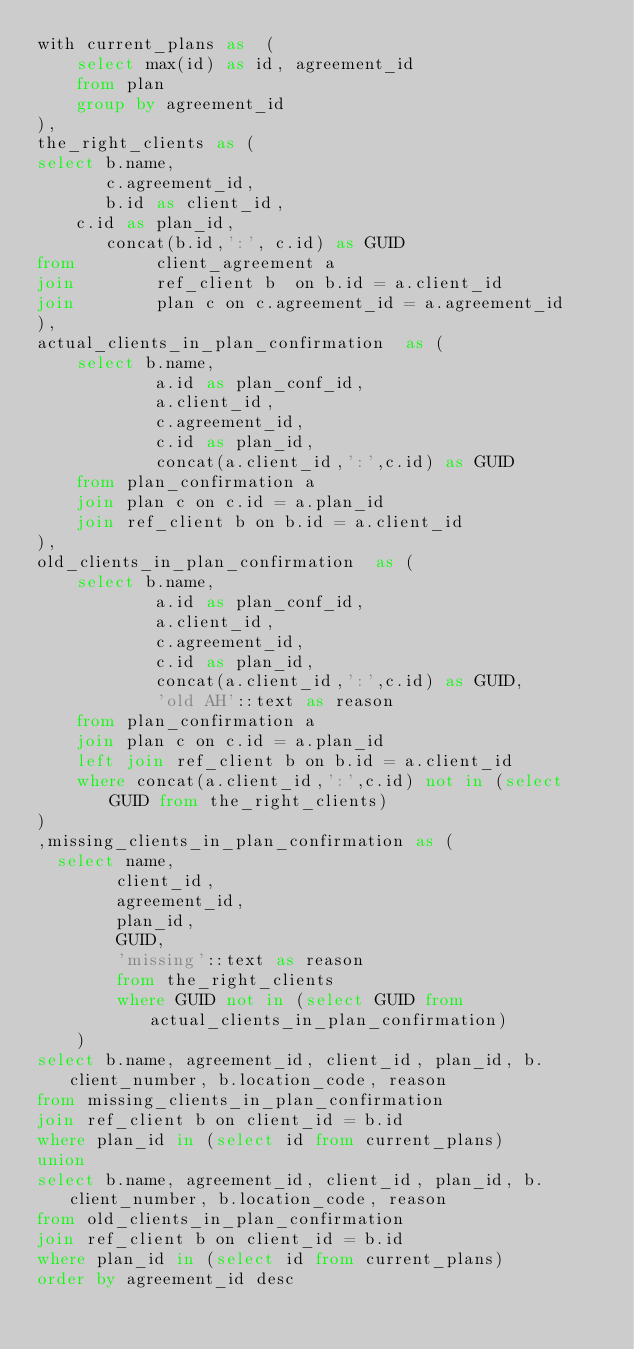<code> <loc_0><loc_0><loc_500><loc_500><_SQL_>with current_plans as  (
    select max(id) as id, agreement_id 
    from plan
    group by agreement_id
),
the_right_clients as ( 
select b.name, 
       c.agreement_id,
       b.id as client_id,
    c.id as plan_id,
       concat(b.id,':', c.id) as GUID
from        client_agreement a 
join        ref_client b  on b.id = a.client_id
join        plan c on c.agreement_id = a.agreement_id
),
actual_clients_in_plan_confirmation  as (
    select b.name,
            a.id as plan_conf_id,
            a.client_id,
            c.agreement_id,
            c.id as plan_id,
            concat(a.client_id,':',c.id) as GUID
    from plan_confirmation a
    join plan c on c.id = a.plan_id
    join ref_client b on b.id = a.client_id
),
old_clients_in_plan_confirmation  as (
    select b.name,
            a.id as plan_conf_id,
            a.client_id,
            c.agreement_id,
            c.id as plan_id,
            concat(a.client_id,':',c.id) as GUID,
            'old AH'::text as reason
    from plan_confirmation a
    join plan c on c.id = a.plan_id
    left join ref_client b on b.id = a.client_id
    where concat(a.client_id,':',c.id) not in (select GUID from the_right_clients)
)
,missing_clients_in_plan_confirmation as (
  select name,
        client_id,
        agreement_id,
        plan_id,
        GUID,
        'missing'::text as reason
        from the_right_clients
        where GUID not in (select GUID from actual_clients_in_plan_confirmation)
    )
select b.name, agreement_id, client_id, plan_id, b.client_number, b.location_code, reason
from missing_clients_in_plan_confirmation
join ref_client b on client_id = b.id
where plan_id in (select id from current_plans)
union
select b.name, agreement_id, client_id, plan_id, b.client_number, b.location_code, reason
from old_clients_in_plan_confirmation
join ref_client b on client_id = b.id
where plan_id in (select id from current_plans)
order by agreement_id desc
</code> 